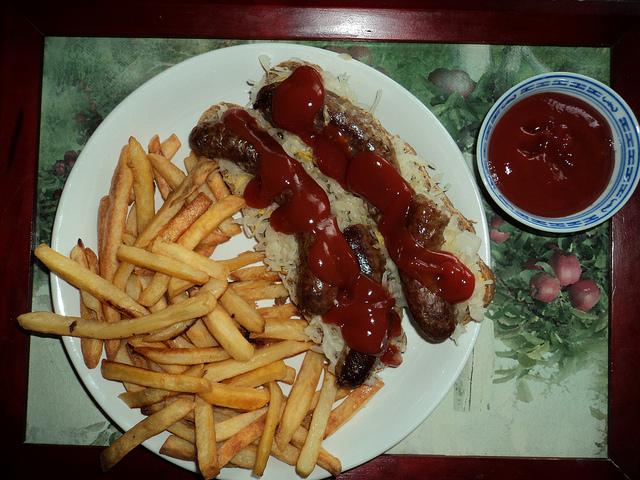What pattern is the paper?
Be succinct. Floral. What is the red thing?
Short answer required. Ketchup. Has this picture been digitally altered?
Quick response, please. No. What is printed on the placemat?
Concise answer only. Apples. Does this meal contain pasta?
Be succinct. No. What color is the sauce?
Give a very brief answer. Red. Is this a low-protein meal?
Short answer required. No. What kind of French fries are these?
Short answer required. Steak fries. Are the French fries seasoned?
Answer briefly. No. Is this a healthy meal?
Write a very short answer. No. What type of meat is pictured?
Give a very brief answer. Sausage. How many fries are on the plate?
Answer briefly. Lot. Would a vegetarian eat this?
Keep it brief. No. Are there any fruits?
Write a very short answer. No. What pork product can you identify?
Concise answer only. Sausage. What meat topping is on the pizza?
Keep it brief. No pizza. 